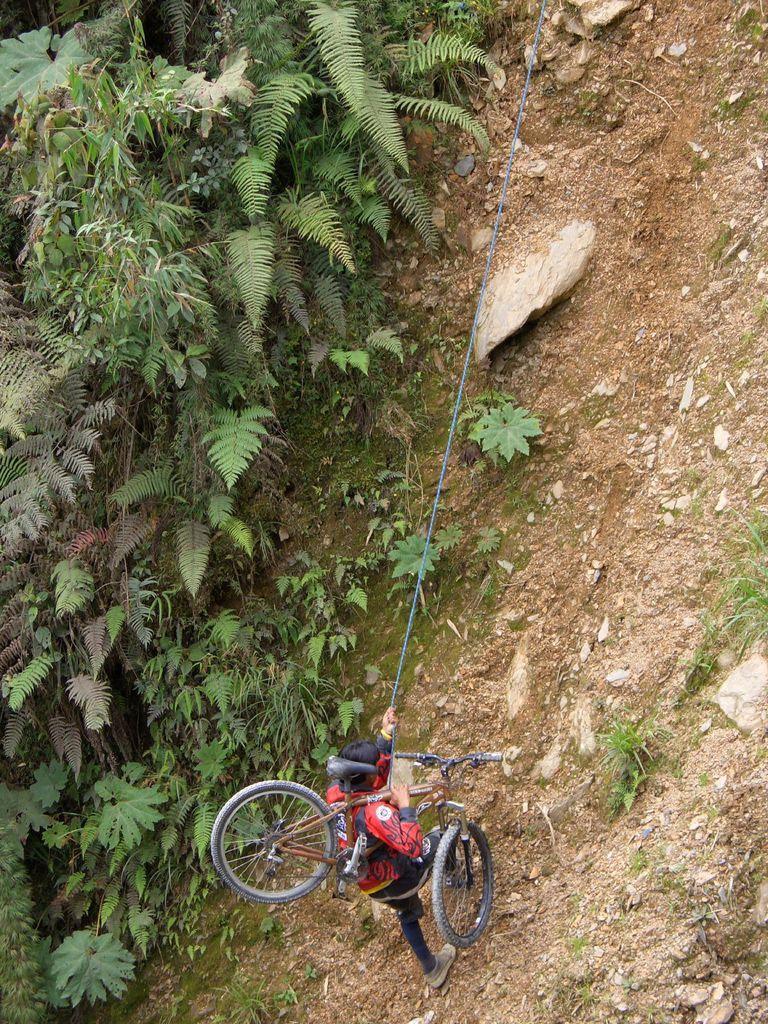Could you give a brief overview of what you see in this image? In this image there is a man walking on the ground by holding the cycle. On the left side there are plants. On the ground there are stones and sand. 